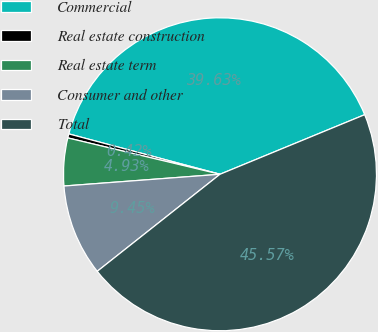<chart> <loc_0><loc_0><loc_500><loc_500><pie_chart><fcel>Commercial<fcel>Real estate construction<fcel>Real estate term<fcel>Consumer and other<fcel>Total<nl><fcel>39.63%<fcel>0.42%<fcel>4.93%<fcel>9.45%<fcel>45.57%<nl></chart> 